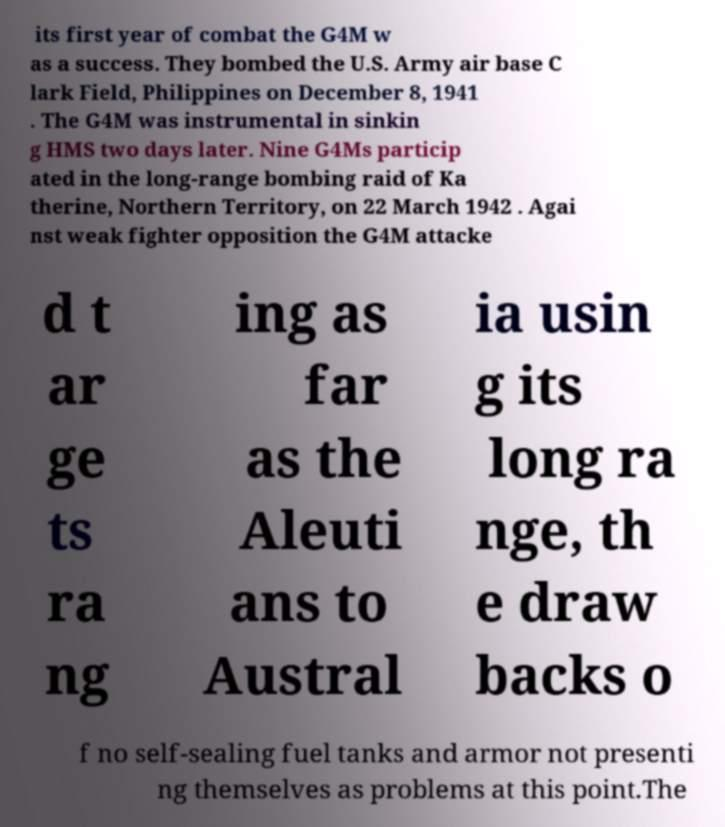Could you assist in decoding the text presented in this image and type it out clearly? its first year of combat the G4M w as a success. They bombed the U.S. Army air base C lark Field, Philippines on December 8, 1941 . The G4M was instrumental in sinkin g HMS two days later. Nine G4Ms particip ated in the long-range bombing raid of Ka therine, Northern Territory, on 22 March 1942 . Agai nst weak fighter opposition the G4M attacke d t ar ge ts ra ng ing as far as the Aleuti ans to Austral ia usin g its long ra nge, th e draw backs o f no self-sealing fuel tanks and armor not presenti ng themselves as problems at this point.The 